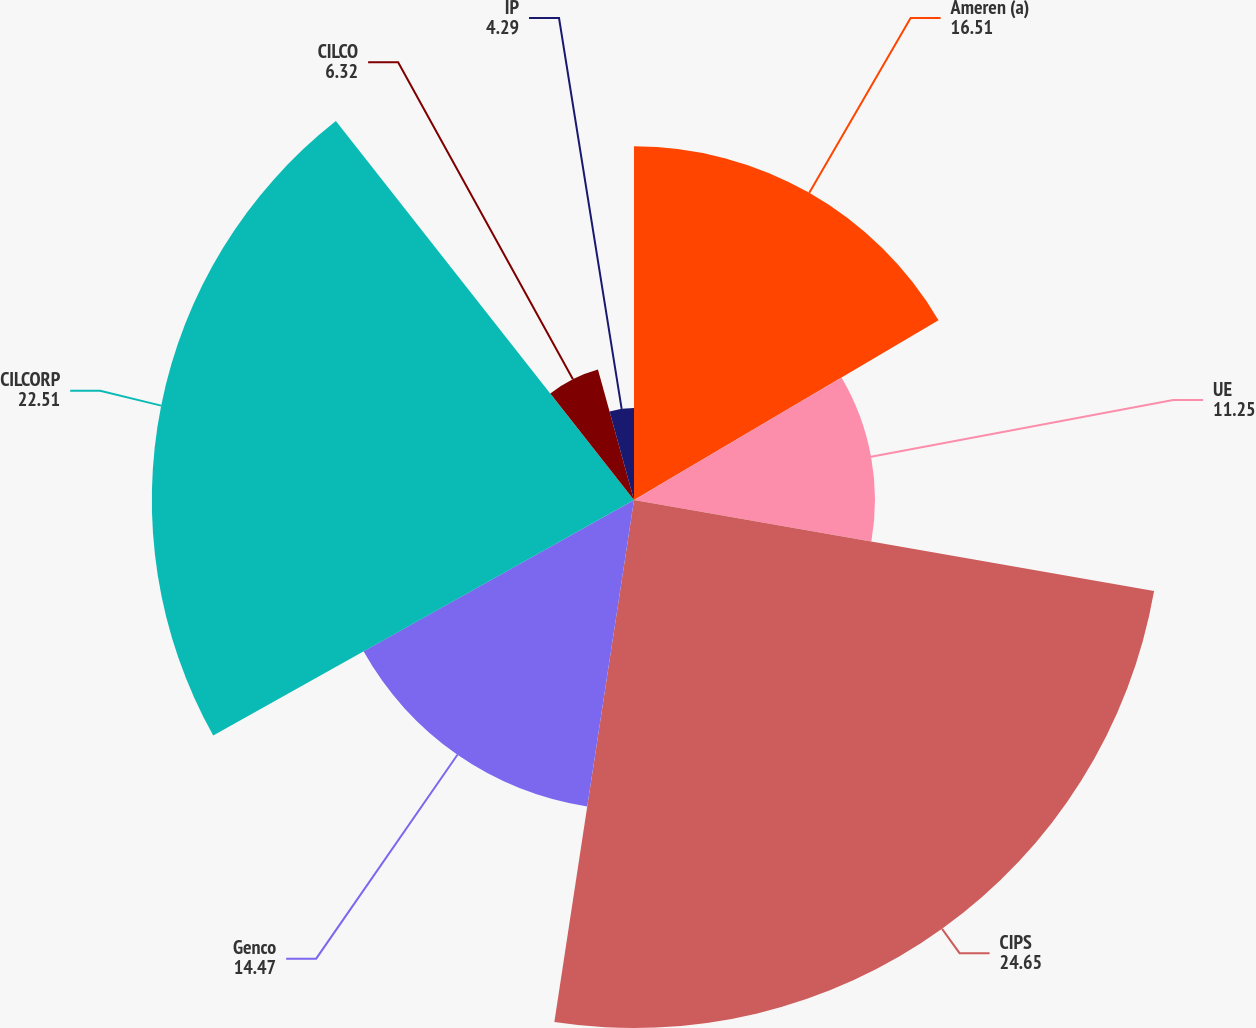<chart> <loc_0><loc_0><loc_500><loc_500><pie_chart><fcel>Ameren (a)<fcel>UE<fcel>CIPS<fcel>Genco<fcel>CILCORP<fcel>CILCO<fcel>IP<nl><fcel>16.51%<fcel>11.25%<fcel>24.65%<fcel>14.47%<fcel>22.51%<fcel>6.32%<fcel>4.29%<nl></chart> 